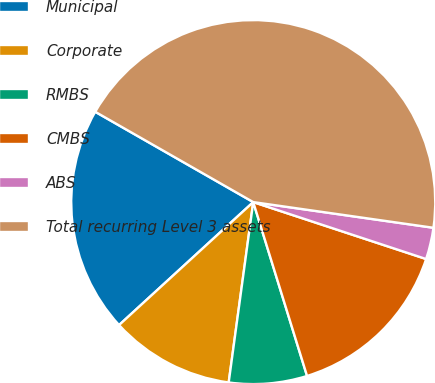<chart> <loc_0><loc_0><loc_500><loc_500><pie_chart><fcel>Municipal<fcel>Corporate<fcel>RMBS<fcel>CMBS<fcel>ABS<fcel>Total recurring Level 3 assets<nl><fcel>20.07%<fcel>11.04%<fcel>6.93%<fcel>15.16%<fcel>2.81%<fcel>43.99%<nl></chart> 